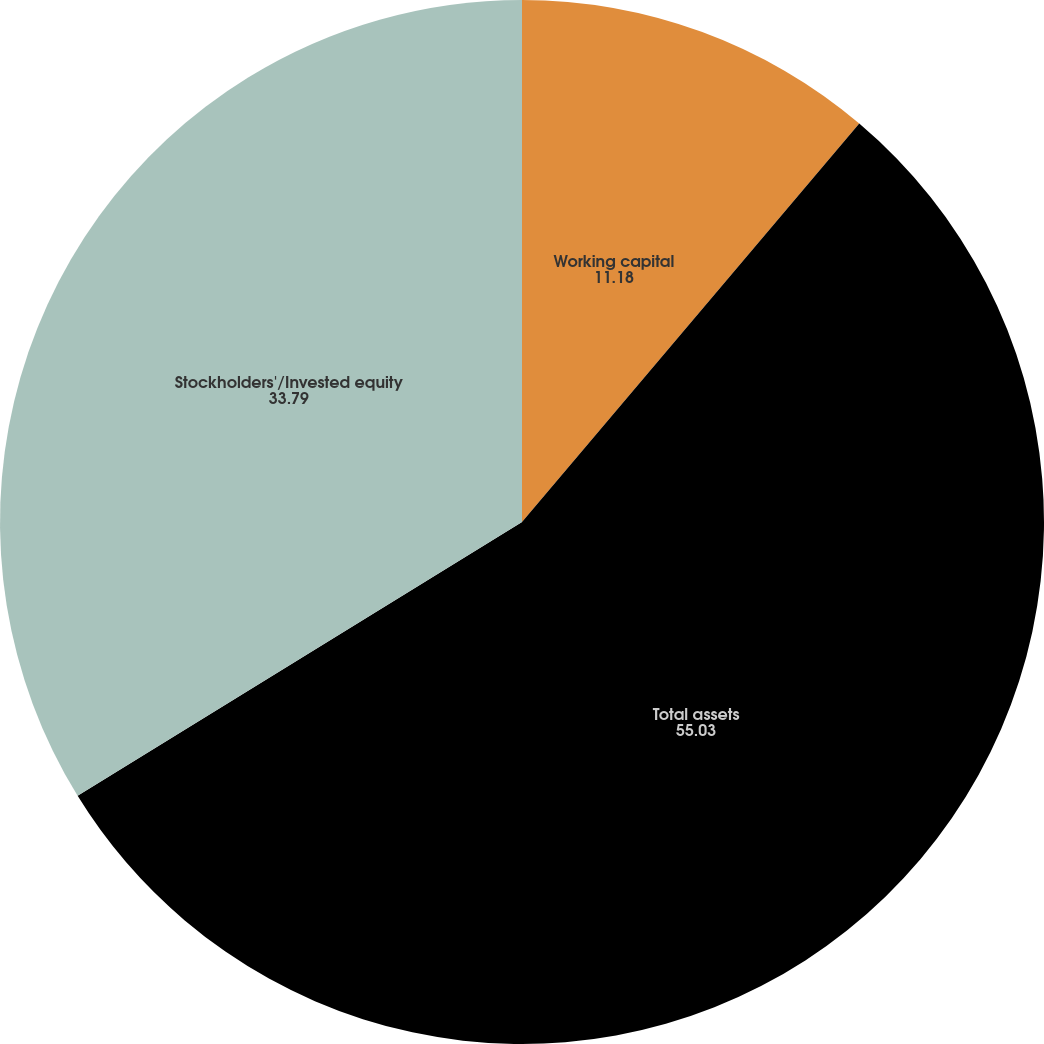Convert chart to OTSL. <chart><loc_0><loc_0><loc_500><loc_500><pie_chart><fcel>Working capital<fcel>Total assets<fcel>Stockholders'/Invested equity<nl><fcel>11.18%<fcel>55.03%<fcel>33.79%<nl></chart> 